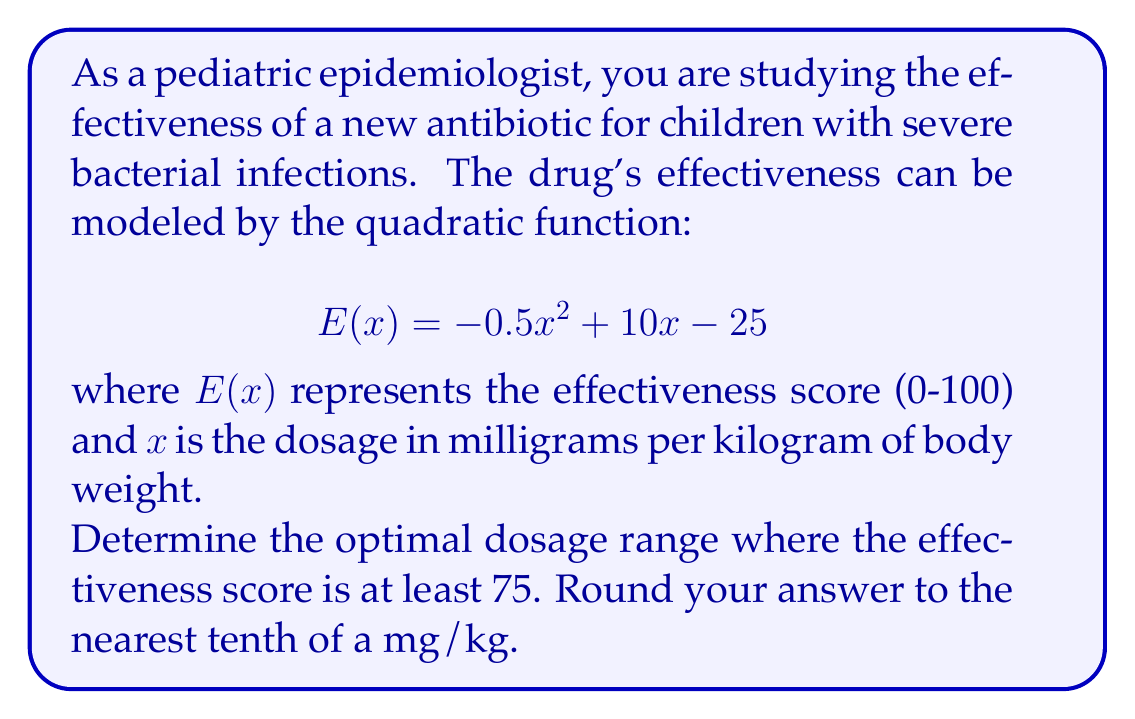Give your solution to this math problem. To solve this problem, we need to follow these steps:

1) The effectiveness score should be at least 75, so we need to solve the inequality:
   $$ E(x) \geq 75 $$

2) Substituting the given function:
   $$ -0.5x^2 + 10x - 25 \geq 75 $$

3) Rearranging the inequality:
   $$ -0.5x^2 + 10x - 100 \geq 0 $$

4) This is a quadratic inequality. To solve it, we first need to find the roots of the quadratic equation:
   $$ -0.5x^2 + 10x - 100 = 0 $$

5) We can solve this using the quadratic formula: $x = \frac{-b \pm \sqrt{b^2 - 4ac}}{2a}$
   Where $a = -0.5$, $b = 10$, and $c = -100$

6) Substituting these values:
   $$ x = \frac{-10 \pm \sqrt{100 - 4(-0.5)(-100)}}{2(-0.5)} = \frac{-10 \pm \sqrt{300}}{-1} $$

7) Simplifying:
   $$ x = 10 \pm \sqrt{300} \approx 10 \pm 17.32 $$

8) Therefore, the roots are approximately:
   $x_1 \approx 27.32$ and $x_2 \approx -7.32$

9) Since we're dealing with dosage, we can discard the negative root. The inequality is satisfied between these roots, so the effectiveness score is at least 75 when:
   $$ 0 \leq x \leq 27.32 $$

10) Rounding to the nearest tenth:
    $$ 0 \leq x \leq 27.3 $$

Thus, the optimal dosage range is from 0 to 27.3 mg/kg.
Answer: The optimal dosage range where the effectiveness score is at least 75 is 0 to 27.3 mg/kg. 